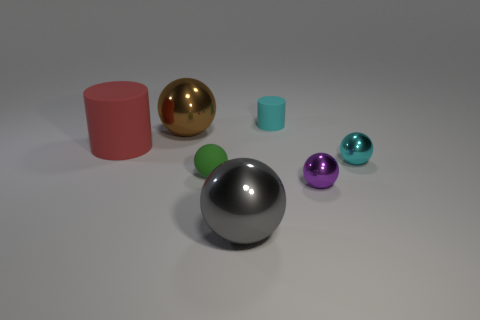What size is the object that is the same color as the tiny cylinder?
Your answer should be very brief. Small. What number of other things have the same material as the brown thing?
Give a very brief answer. 3. There is a thing that is the same color as the small cylinder; what is its shape?
Your answer should be very brief. Sphere. There is a brown thing that is behind the shiny ball that is in front of the purple metallic sphere; how big is it?
Ensure brevity in your answer.  Large. Does the large metallic object behind the small purple metal thing have the same shape as the big metallic object that is in front of the big cylinder?
Offer a very short reply. Yes. Are there the same number of brown metal objects in front of the small green thing and yellow shiny blocks?
Provide a short and direct response. Yes. There is another big shiny object that is the same shape as the big gray object; what color is it?
Keep it short and to the point. Brown. Is the material of the cyan thing that is to the right of the small cyan rubber thing the same as the brown ball?
Offer a terse response. Yes. What number of tiny objects are brown metal spheres or red matte cylinders?
Provide a succinct answer. 0. The rubber sphere is what size?
Provide a succinct answer. Small. 